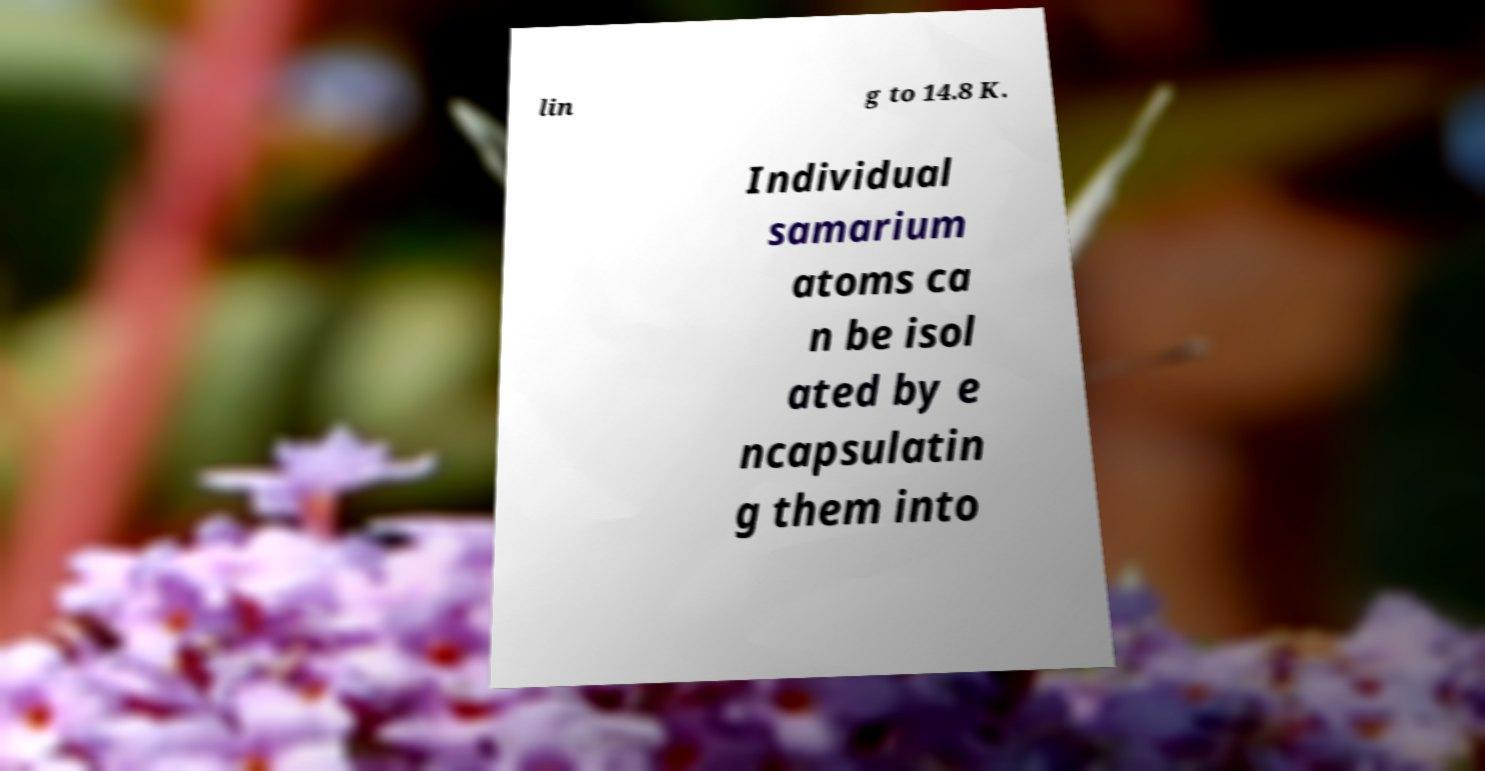I need the written content from this picture converted into text. Can you do that? lin g to 14.8 K. Individual samarium atoms ca n be isol ated by e ncapsulatin g them into 